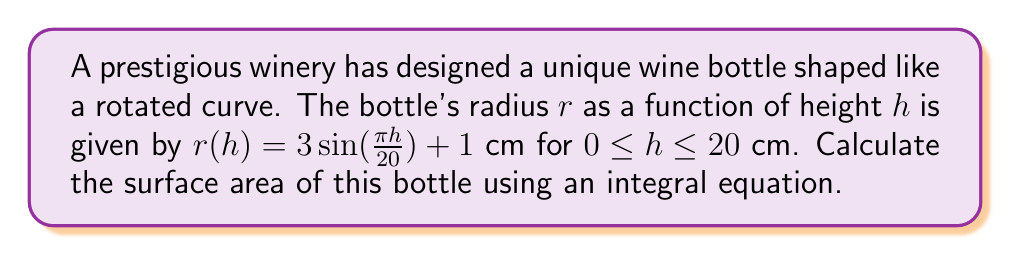Solve this math problem. To calculate the surface area of a solid of revolution, we use the surface area formula:

$$S = 2\pi \int_{a}^{b} r(h) \sqrt{1 + [r'(h)]^2} dh$$

Where $r(h)$ is the radius function and $r'(h)$ is its derivative.

Step 1: Find $r'(h)$
$$r'(h) = \frac{d}{dh}[3\sin(\frac{\pi h}{20}) + 1] = \frac{3\pi}{20}\cos(\frac{\pi h}{20})$$

Step 2: Set up the integral
$$S = 2\pi \int_{0}^{20} [3\sin(\frac{\pi h}{20}) + 1] \sqrt{1 + [\frac{3\pi}{20}\cos(\frac{\pi h}{20})]^2} dh$$

Step 3: Simplify the integrand
$$S = 2\pi \int_{0}^{20} [3\sin(\frac{\pi h}{20}) + 1] \sqrt{1 + \frac{9\pi^2}{400}\cos^2(\frac{\pi h}{20})} dh$$

Step 4: This integral cannot be solved analytically, so we must use numerical integration methods. Using a computer algebra system or numerical integration tool, we can approximate the result:

$$S \approx 289.62 \text{ cm}^2$$
Answer: $289.62 \text{ cm}^2$ 